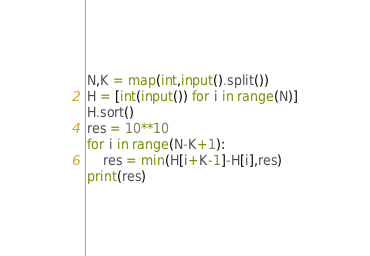<code> <loc_0><loc_0><loc_500><loc_500><_Python_>N,K = map(int,input().split())
H = [int(input()) for i in range(N)]
H.sort()
res = 10**10
for i in range(N-K+1):
    res = min(H[i+K-1]-H[i],res)
print(res)</code> 